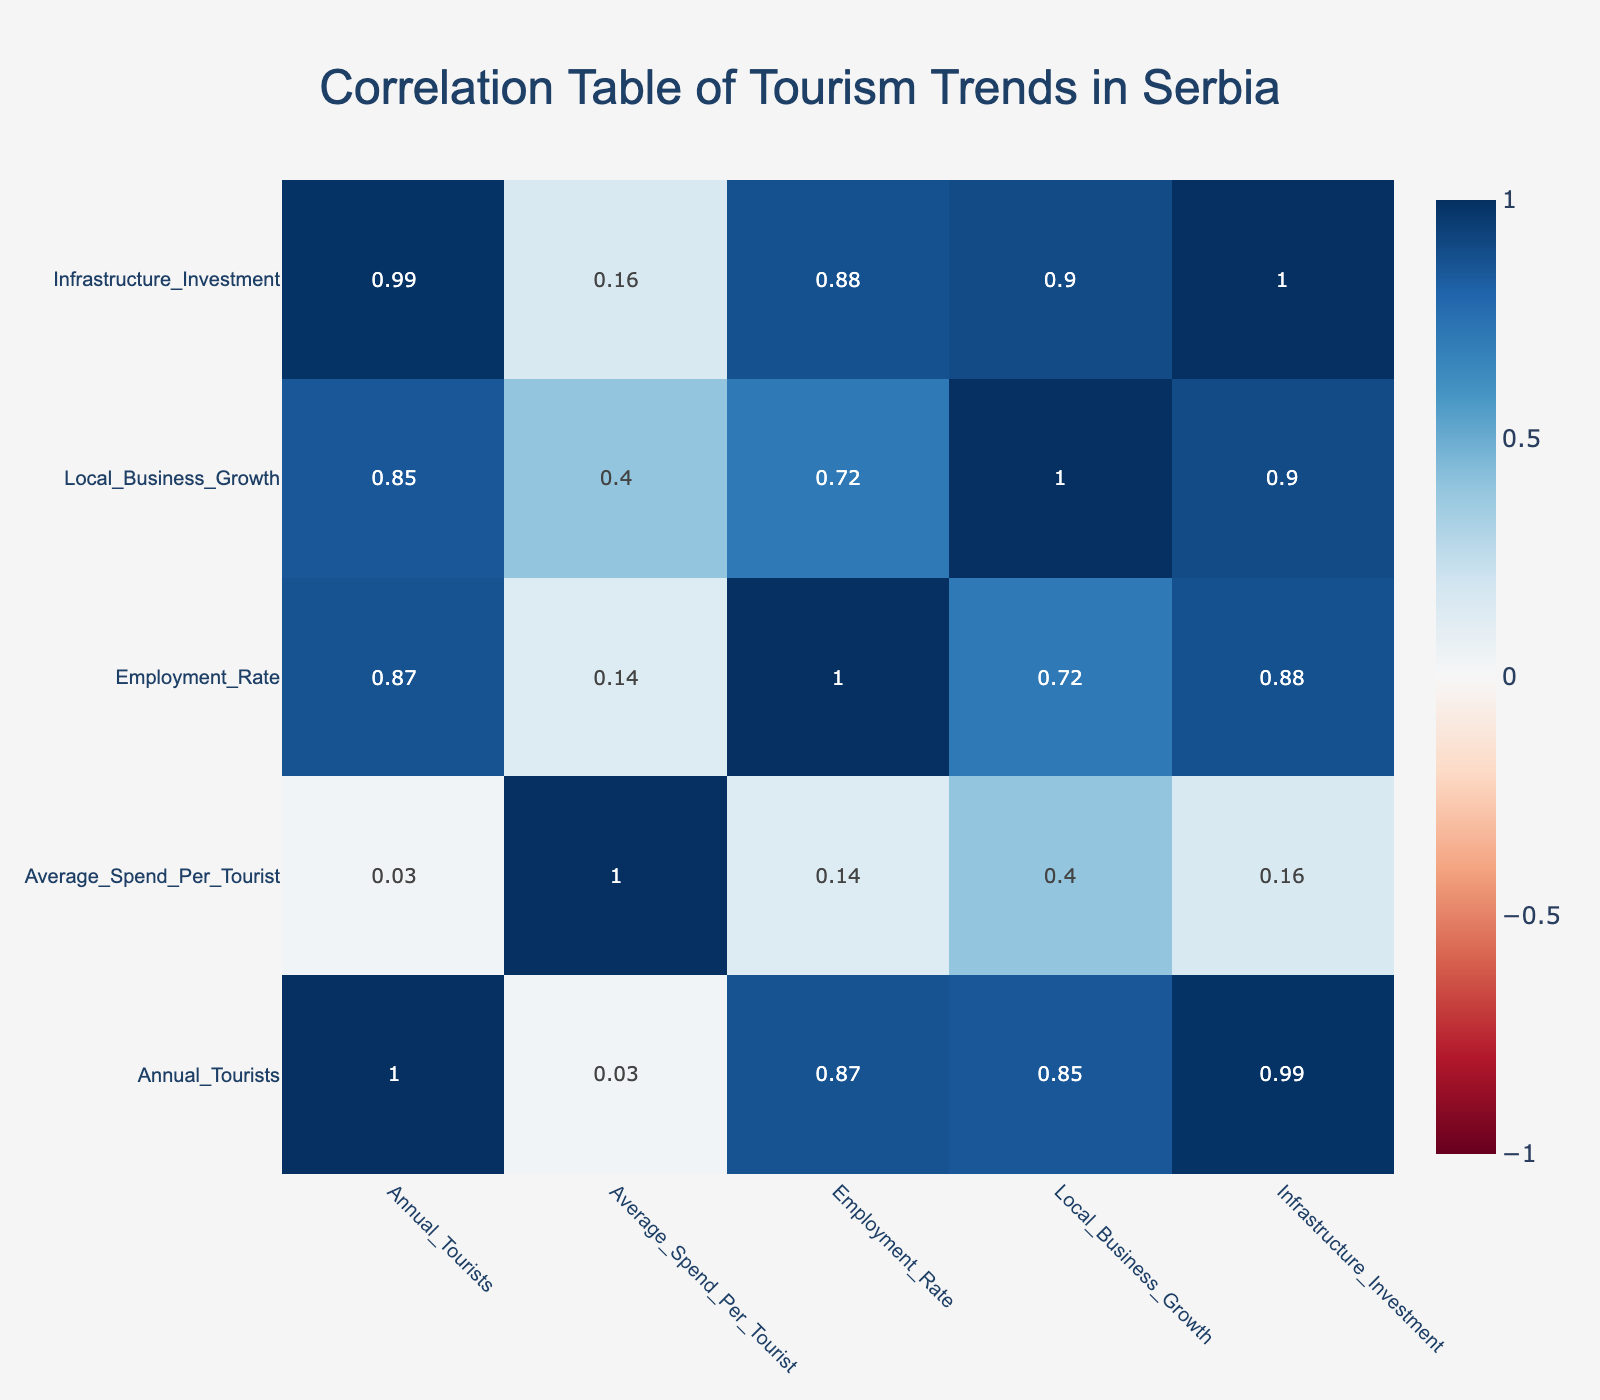What is the infrastructure investment for Belgrade? From the table, the row corresponding to Belgrade indicates that the infrastructure investment is 2,000,000.
Answer: 2,000,000 What is the average spend per tourist in Kopaonik? Looking at the Kopaonik row, the average spend per tourist is noted as 150.
Answer: 150 Is the employment rate in Tara National Park greater than that in Subotica? The employment rate for Tara National Park is 45, while for Subotica, it is 50. Therefore, Tara National Park does not have a greater employment rate.
Answer: No What is the total number of annual tourists in all attractions combined? We add the annual tourists from each row: 3,000,000 (Novi Sad) + 5,000,000 (Belgrade) + 800,000 (Niš) + 500,000 (Kopaonik) + 300,000 (Subotica) + 200,000 (Tara National Park) + 250,000 (Sremski Karlovci) + 150,000 (Đerdap National Park) = 10,400,000.
Answer: 10,400,000 What is the difference in average spend per tourist between the highest and lowest values in the table? The maximum average spend per tourist is 150 (Kopaonik) and the minimum is 50 (Niš). The difference is calculated as 150 - 50 = 100.
Answer: 100 Which local attraction has the highest local business growth? Reviewing the Local_Business_Growth column, Belgrade has the highest value of 10 compared to other attractions.
Answer: Belgrade Is there a positive correlation between annual tourists and local business growth? To determine correlation visually from the heatmap, we examine the correlation value between Annual_Tourists and Local_Business_Growth, which is positive. Therefore, yes, there is a positive correlation.
Answer: Yes What is the average employment rate across all attractions? The employment rates are: 65 (Novi Sad), 70 (Belgrade), 55 (Niš), 60 (Kopaonik), 50 (Subotica), 45 (Tara National Park), 55 (Sremski Karlovci), and 50 (Đerdap National Park). The average is (65 + 70 + 55 + 60 + 50 + 45 + 55 + 50) / 8 = 55.
Answer: 55 Does Kopaonik have a higher average spend per tourist compared to Sremski Karlovci? Kopaonik has an average spend of 150 while Sremski Karlovci has 80. Since 150 is greater than 80, the statement is true.
Answer: Yes 